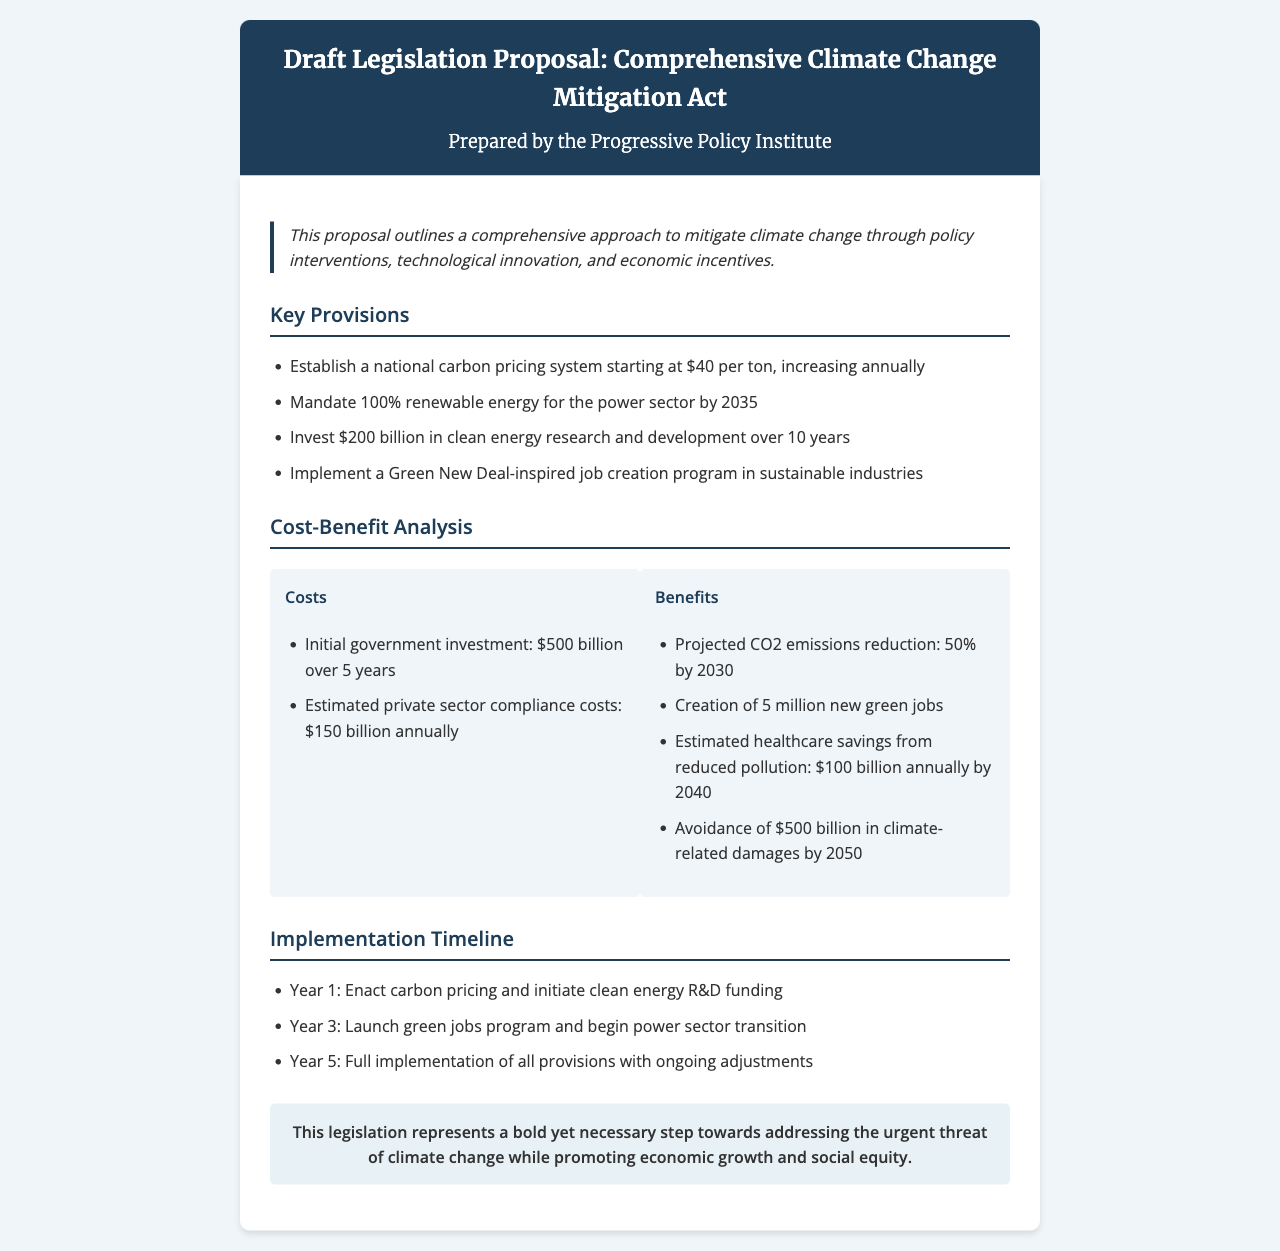What is the title of the document? The title summarizes the main subject of the document, which is evident in the header.
Answer: Comprehensive Climate Change Mitigation Act Who prepared the proposal? The document states who created the proposal in the subtitle area.
Answer: Progressive Policy Institute What is the initial government investment amount? The document specifies costs related to government investments under the cost-benefit analysis section.
Answer: $500 billion What percentage reduction in CO2 emissions is projected by 2030? The projected CO2 emissions reduction is listed directly in the benefits section of the document.
Answer: 50% By what year does the power sector need to be 100% renewable? This timeline is included in the key provisions explaining policy deadlines.
Answer: 2035 How many new green jobs are expected to be created? The document includes a specific number related to job creation in the benefits section.
Answer: 5 million What is the estimated annual healthcare savings from reduced pollution by 2040? This figure is provided under the benefits section and provides a financial context.
Answer: $100 billion What is the carbon pricing starting rate per ton? This information can be found in the key provisions highlighting assessment options.
Answer: $40 What is the timeline for the full implementation of all provisions? The implementation timeline details the stages for the proposed legislation's execution.
Answer: Year 5 